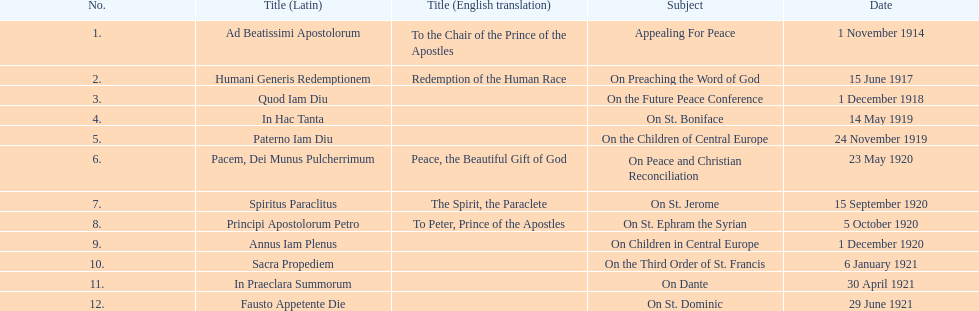What is the count of encyclopedias featuring subjects related to children? 2. 